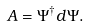Convert formula to latex. <formula><loc_0><loc_0><loc_500><loc_500>A = \Psi ^ { \dagger } d \Psi .</formula> 